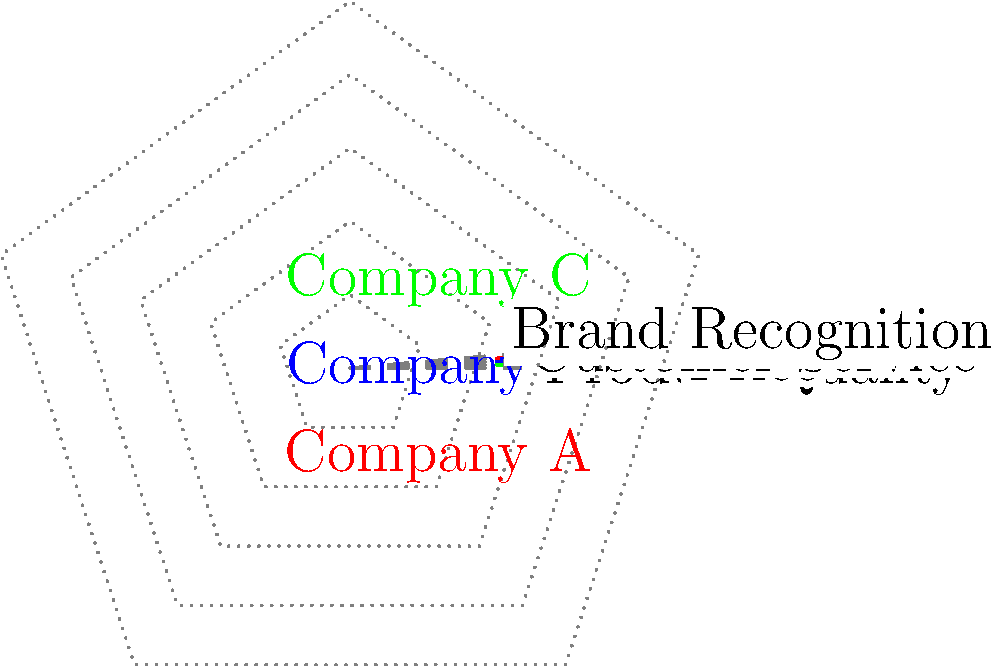As the dean of a prestigious business school, you're teaching a class on competitive analysis. Using the radar chart provided, which company has the highest overall performance across all five dimensions, and what strategic recommendation would you give to Company B to improve its competitive position? To answer this question, we need to analyze the radar chart and compare the performance of the three companies across all five dimensions:

1. Evaluate each company's performance:
   Company A: Balanced performance with strengths in Product Quality and Innovation.
   Company B: Strong in Price and Customer Service, weak in Innovation.
   Company C: Excels in Product Quality and Brand Recognition, weak in Price.

2. Calculate the total area covered by each company's polygon:
   The larger the area, the better the overall performance.
   By visual inspection, Company C covers the largest area.

3. Identify Company C as the highest overall performer due to its larger coverage area.

4. Analyze Company B's weaknesses:
   - Low scores in Innovation and Product Quality
   - Average score in Brand Recognition

5. Strategic recommendation for Company B:
   a) Invest in R&D to improve Innovation score
   b) Enhance Product Quality through better materials or manufacturing processes
   c) Leverage strong Customer Service to build Brand Recognition
   d) Maintain strength in Price and Customer Service

6. Formulate a concise recommendation focusing on the most critical areas for improvement: Innovation and Product Quality.
Answer: Company C has the highest overall performance. Recommend Company B to invest in R&D for innovation and improve product quality while leveraging its strong customer service. 